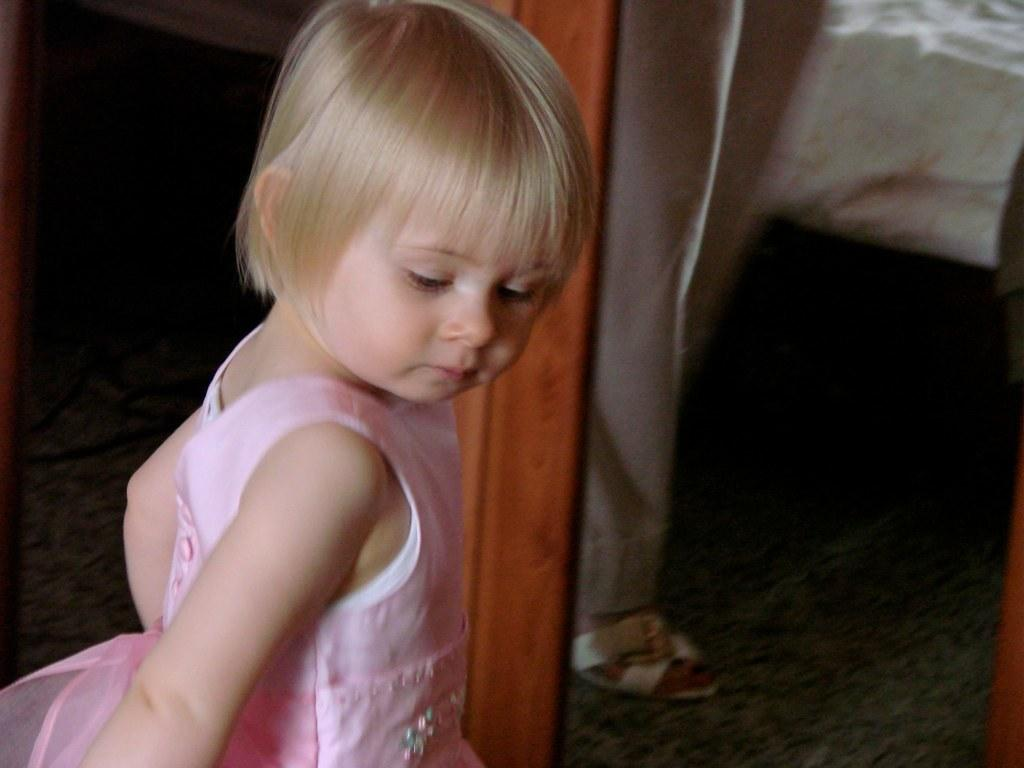Who is the main subject in the image? There is a little girl in the image. What type of structure can be seen in the image? There is a wooden structure in the image. Whose legs are visible in the image? The legs of another person are visible in the image. What type of furniture is present in the image? There is a bed in the image. How many boys are present in the image? There is no boy present in the image. 